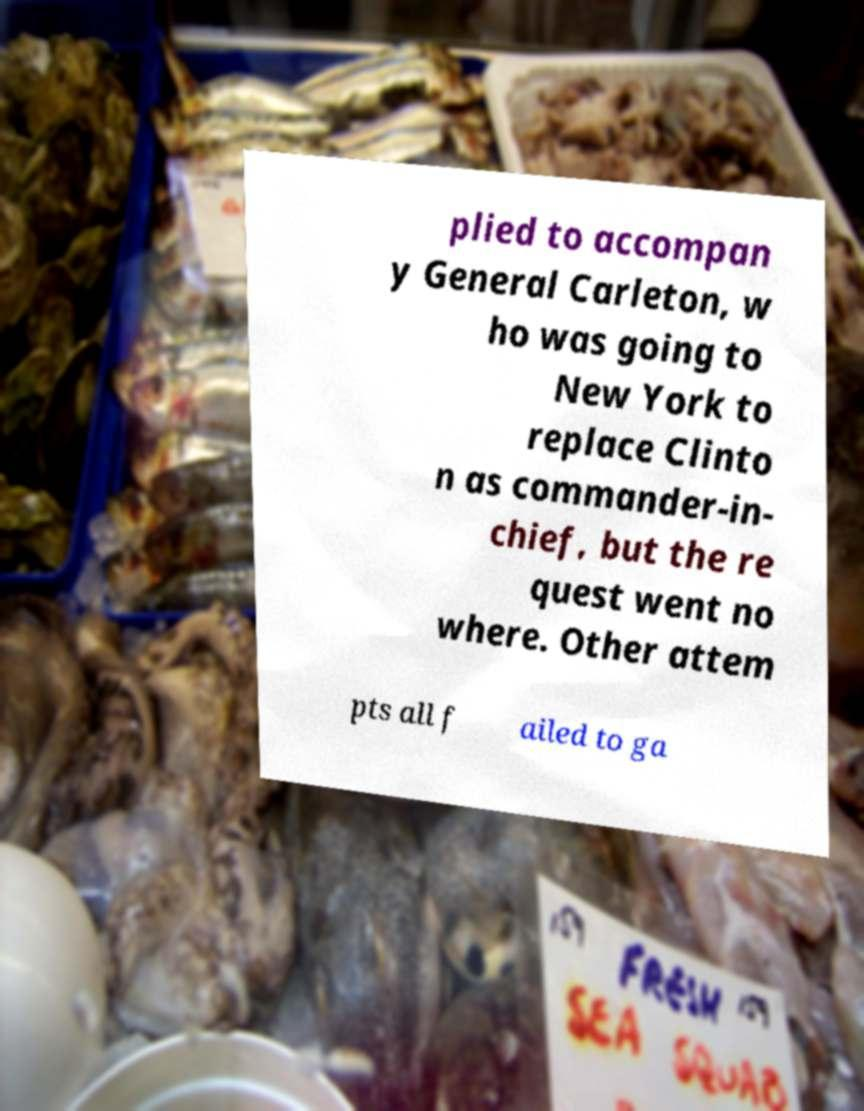What messages or text are displayed in this image? I need them in a readable, typed format. plied to accompan y General Carleton, w ho was going to New York to replace Clinto n as commander-in- chief, but the re quest went no where. Other attem pts all f ailed to ga 